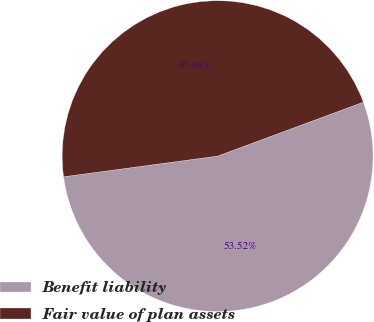Convert chart to OTSL. <chart><loc_0><loc_0><loc_500><loc_500><pie_chart><fcel>Benefit liability<fcel>Fair value of plan assets<nl><fcel>53.52%<fcel>46.48%<nl></chart> 